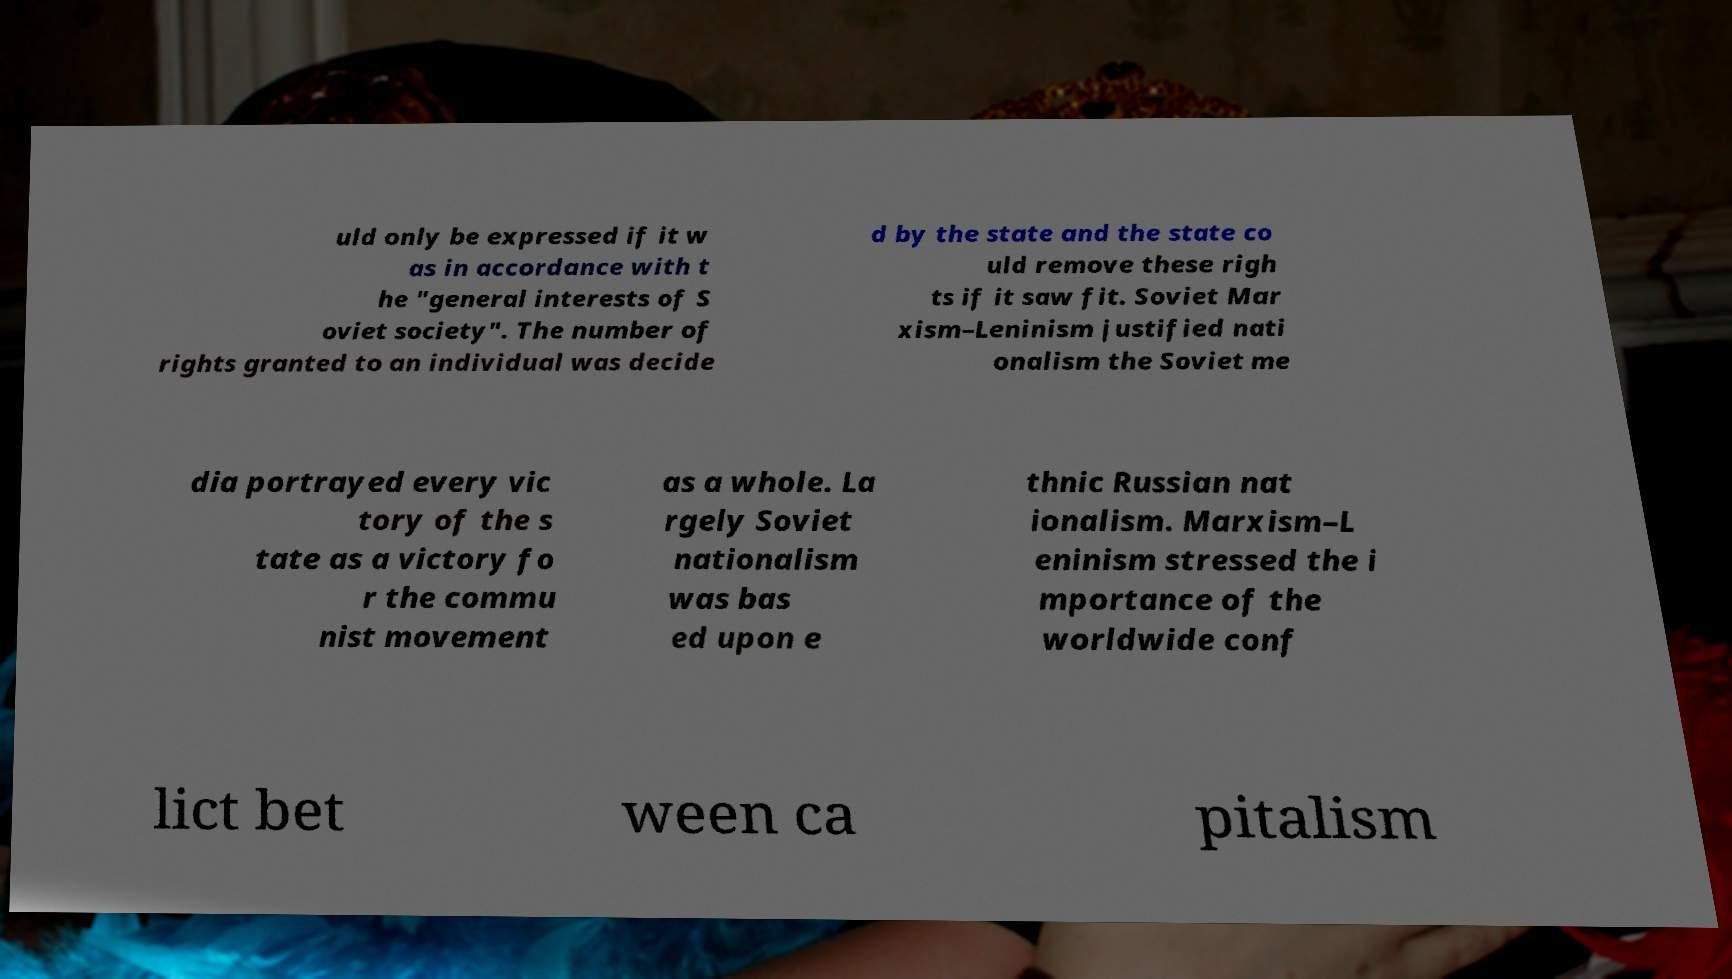What messages or text are displayed in this image? I need them in a readable, typed format. uld only be expressed if it w as in accordance with t he "general interests of S oviet society". The number of rights granted to an individual was decide d by the state and the state co uld remove these righ ts if it saw fit. Soviet Mar xism–Leninism justified nati onalism the Soviet me dia portrayed every vic tory of the s tate as a victory fo r the commu nist movement as a whole. La rgely Soviet nationalism was bas ed upon e thnic Russian nat ionalism. Marxism–L eninism stressed the i mportance of the worldwide conf lict bet ween ca pitalism 